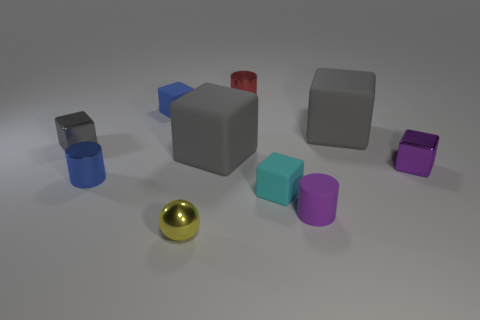How many gray blocks must be subtracted to get 1 gray blocks? 2 Subtract all metallic cylinders. How many cylinders are left? 1 Subtract 1 cylinders. How many cylinders are left? 2 Subtract all cyan blocks. How many blocks are left? 5 Subtract all red cylinders. How many gray cubes are left? 3 Subtract all blocks. How many objects are left? 4 Subtract 1 blue blocks. How many objects are left? 9 Subtract all green cylinders. Subtract all red cubes. How many cylinders are left? 3 Subtract all brown spheres. Subtract all matte cylinders. How many objects are left? 9 Add 5 gray objects. How many gray objects are left? 8 